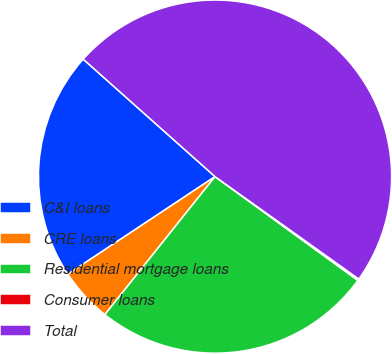Convert chart to OTSL. <chart><loc_0><loc_0><loc_500><loc_500><pie_chart><fcel>C&I loans<fcel>CRE loans<fcel>Residential mortgage loans<fcel>Consumer loans<fcel>Total<nl><fcel>20.9%<fcel>4.96%<fcel>25.72%<fcel>0.15%<fcel>48.27%<nl></chart> 